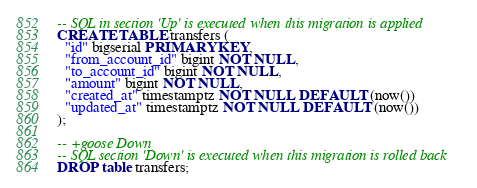Convert code to text. <code><loc_0><loc_0><loc_500><loc_500><_SQL_>-- SQL in section 'Up' is executed when this migration is applied
CREATE TABLE transfers (
  "id" bigserial PRIMARY KEY,
  "from_account_id" bigint NOT NULL,
  "to_account_id" bigint NOT NULL,
  "amount" bigint NOT NULL,
  "created_at" timestamptz NOT NULL DEFAULT (now())
  "updated_at" timestamptz NOT NULL DEFAULT (now())
);

-- +goose Down
-- SQL section 'Down' is executed when this migration is rolled back
DROP table transfers;
</code> 